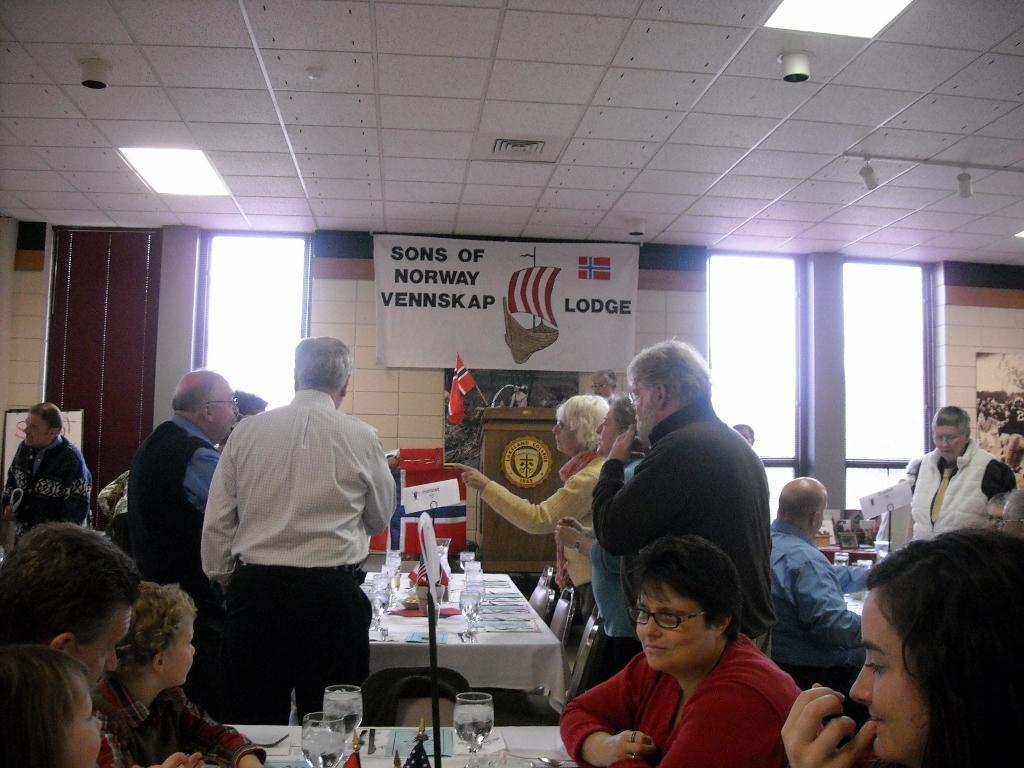Can you describe this image briefly? Here some people are standing and some people are sitting, there are tables and chairs, there are glasses and these are windows. 